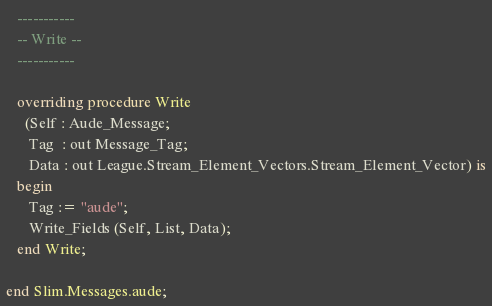<code> <loc_0><loc_0><loc_500><loc_500><_Ada_>
   -----------
   -- Write --
   -----------

   overriding procedure Write
     (Self : Aude_Message;
      Tag  : out Message_Tag;
      Data : out League.Stream_Element_Vectors.Stream_Element_Vector) is
   begin
      Tag := "aude";
      Write_Fields (Self, List, Data);
   end Write;

end Slim.Messages.aude;
</code> 